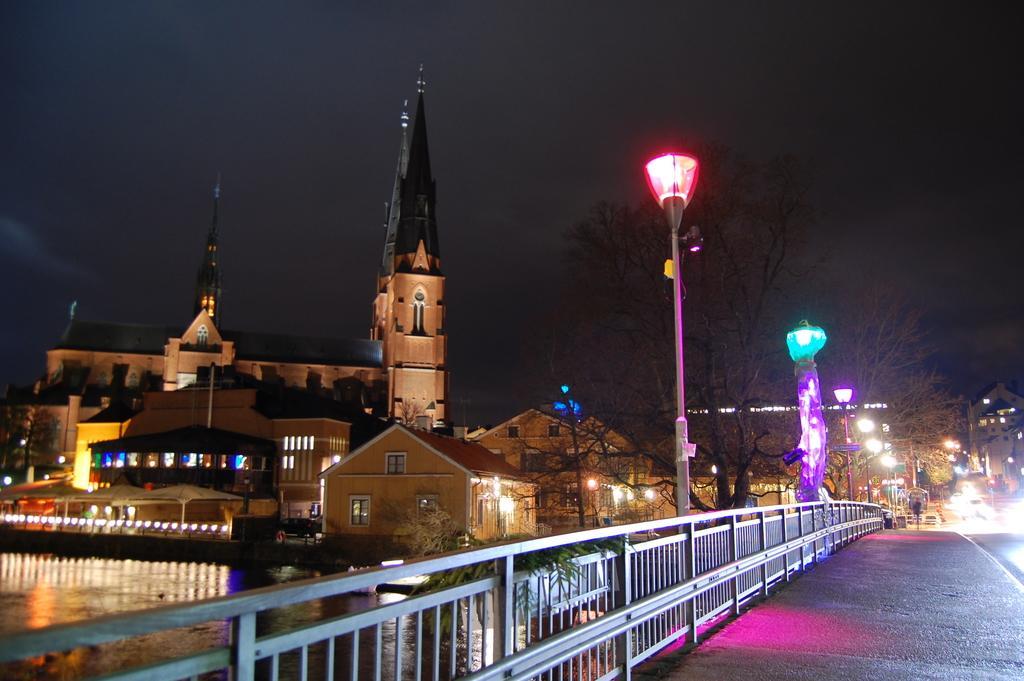Describe this image in one or two sentences. This looks like a river with the water flowing. These are the buildings with windows and lights. I think this is the bridge. I can see the trees. These look like barricades. 